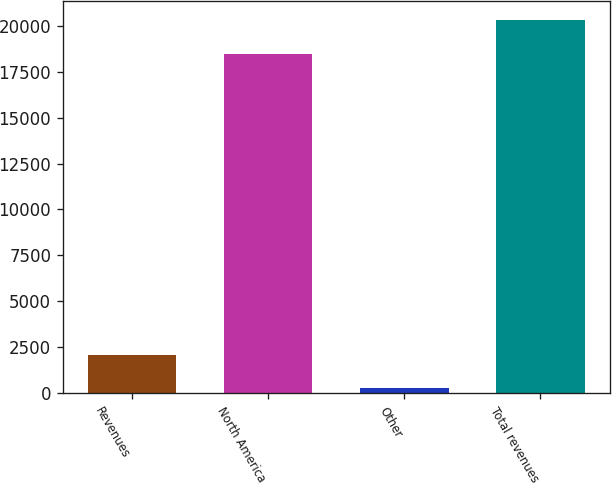Convert chart. <chart><loc_0><loc_0><loc_500><loc_500><bar_chart><fcel>Revenues<fcel>North America<fcel>Other<fcel>Total revenues<nl><fcel>2101<fcel>18480<fcel>253<fcel>20328<nl></chart> 